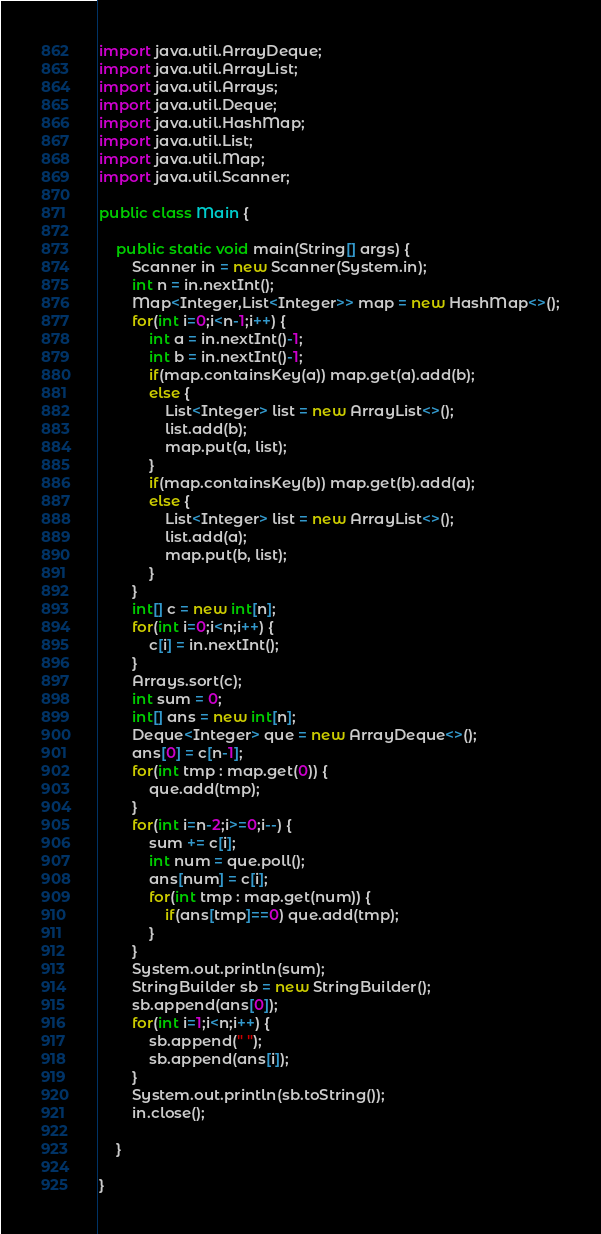<code> <loc_0><loc_0><loc_500><loc_500><_Java_>import java.util.ArrayDeque;
import java.util.ArrayList;
import java.util.Arrays;
import java.util.Deque;
import java.util.HashMap;
import java.util.List;
import java.util.Map;
import java.util.Scanner;

public class Main {

	public static void main(String[] args) {
		Scanner in = new Scanner(System.in);
		int n = in.nextInt();
		Map<Integer,List<Integer>> map = new HashMap<>();
		for(int i=0;i<n-1;i++) {
			int a = in.nextInt()-1;
			int b = in.nextInt()-1;
			if(map.containsKey(a)) map.get(a).add(b);
			else {
				List<Integer> list = new ArrayList<>();
				list.add(b);
				map.put(a, list);
			}
			if(map.containsKey(b)) map.get(b).add(a);
			else {
				List<Integer> list = new ArrayList<>();
				list.add(a);
				map.put(b, list);
			}
		}
		int[] c = new int[n];
		for(int i=0;i<n;i++) {
			c[i] = in.nextInt();
		}
		Arrays.sort(c);
		int sum = 0;
		int[] ans = new int[n];
		Deque<Integer> que = new ArrayDeque<>();
		ans[0] = c[n-1];
		for(int tmp : map.get(0)) {
			que.add(tmp);
		}
		for(int i=n-2;i>=0;i--) {
			sum += c[i];
			int num = que.poll();
			ans[num] = c[i];
			for(int tmp : map.get(num)) {
				if(ans[tmp]==0) que.add(tmp);
			}
		}
		System.out.println(sum);
		StringBuilder sb = new StringBuilder();
		sb.append(ans[0]);
		for(int i=1;i<n;i++) {
			sb.append(" ");
			sb.append(ans[i]);
		}
		System.out.println(sb.toString());
		in.close();

	}

}
</code> 